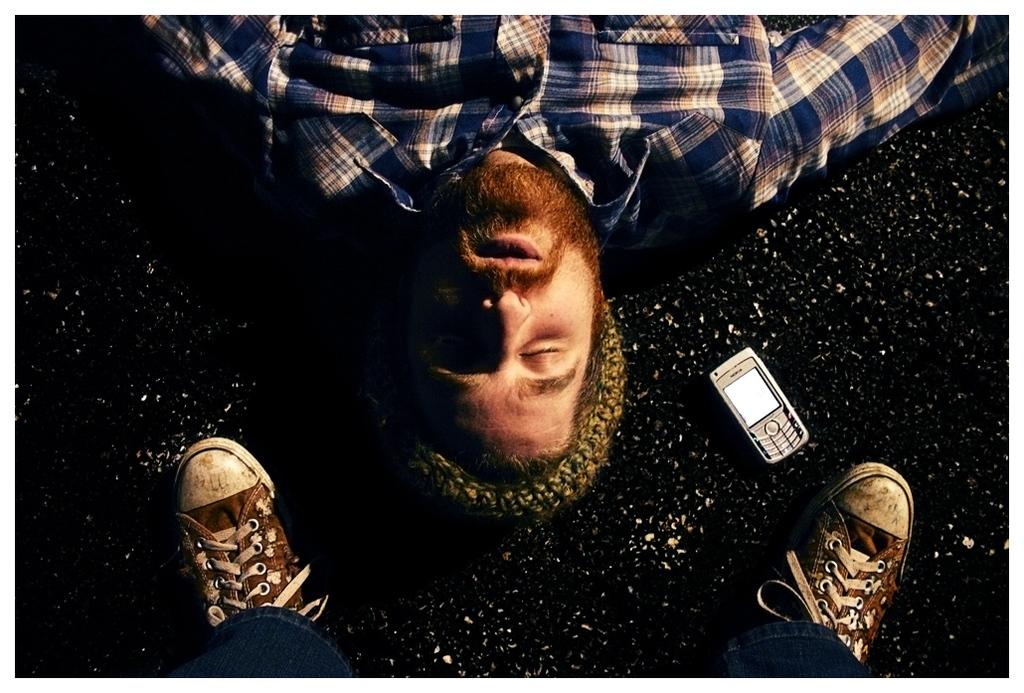What is the main subject of the image? There is a person lying on the road in the image. What object can be seen in the image besides the person? There is a mobile in the image. Can you describe the person's legs in the image? A person's legs with footwear are visible at the bottom of the image. What type of feather can be seen on the person's head in the image? There is no feather present on the person's head in the image. How many pizzas are being delivered to the person in the image? There is no mention of pizzas or delivery in the image. What color is the berry that the person is holding in the image? There is no berry present in the image. 